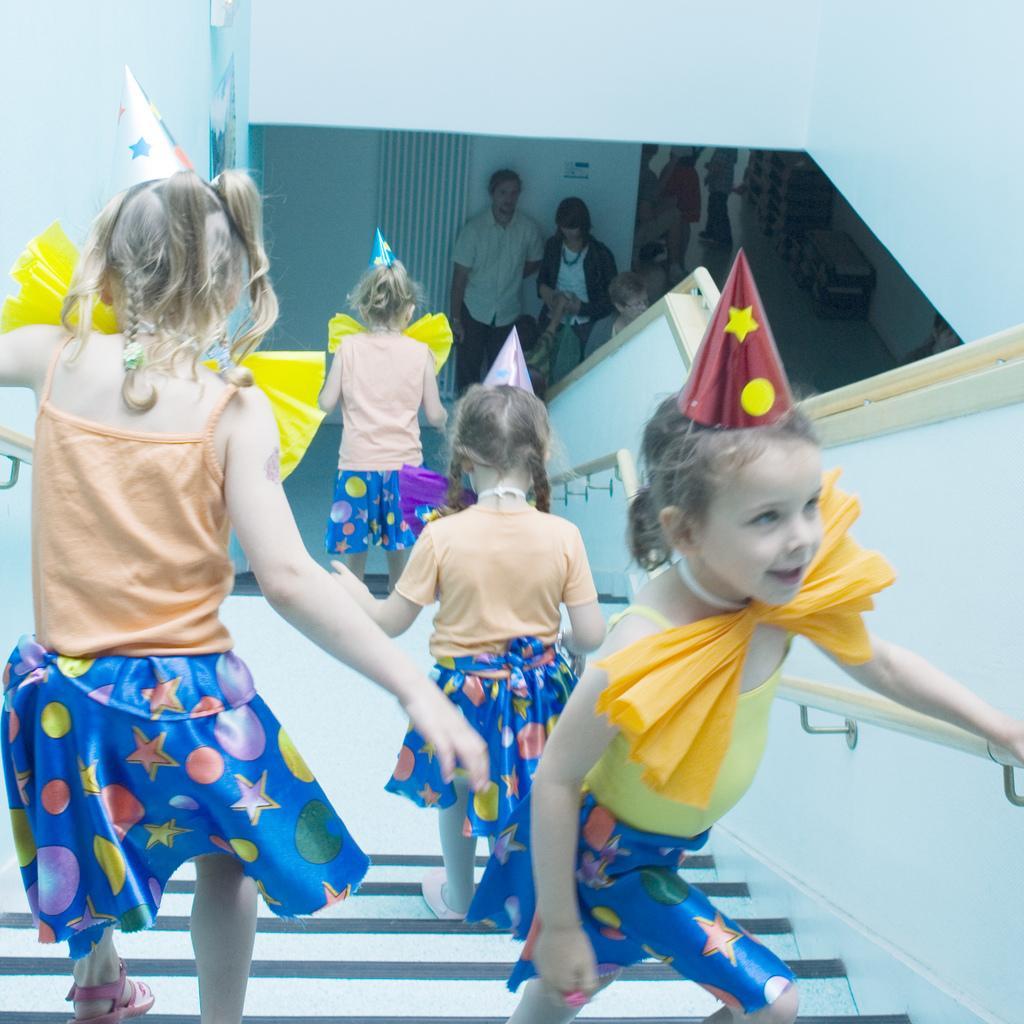In one or two sentences, can you explain what this image depicts? In the picture we can see some children are walking on the steps holding the railing and down the steps we can see two people are standing near the wall. 